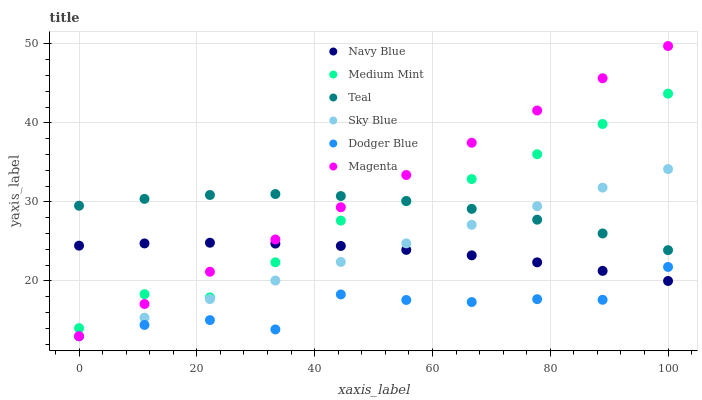Does Dodger Blue have the minimum area under the curve?
Answer yes or no. Yes. Does Magenta have the maximum area under the curve?
Answer yes or no. Yes. Does Navy Blue have the minimum area under the curve?
Answer yes or no. No. Does Navy Blue have the maximum area under the curve?
Answer yes or no. No. Is Magenta the smoothest?
Answer yes or no. Yes. Is Dodger Blue the roughest?
Answer yes or no. Yes. Is Navy Blue the smoothest?
Answer yes or no. No. Is Navy Blue the roughest?
Answer yes or no. No. Does Dodger Blue have the lowest value?
Answer yes or no. Yes. Does Navy Blue have the lowest value?
Answer yes or no. No. Does Magenta have the highest value?
Answer yes or no. Yes. Does Navy Blue have the highest value?
Answer yes or no. No. Is Sky Blue less than Medium Mint?
Answer yes or no. Yes. Is Medium Mint greater than Dodger Blue?
Answer yes or no. Yes. Does Magenta intersect Medium Mint?
Answer yes or no. Yes. Is Magenta less than Medium Mint?
Answer yes or no. No. Is Magenta greater than Medium Mint?
Answer yes or no. No. Does Sky Blue intersect Medium Mint?
Answer yes or no. No. 